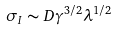Convert formula to latex. <formula><loc_0><loc_0><loc_500><loc_500>\sigma _ { I } \sim D \gamma ^ { 3 / 2 } \lambda ^ { 1 / 2 }</formula> 